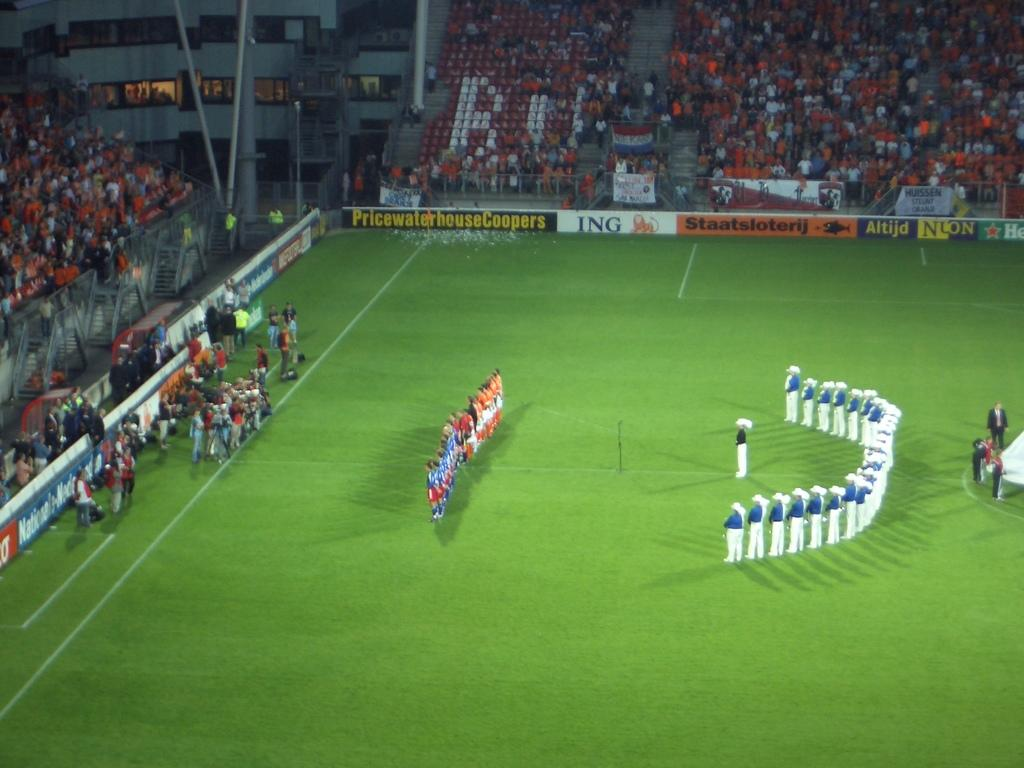<image>
Present a compact description of the photo's key features. The soccer team lines up at midfield in a stadium with banners for ING and Saatsloterij. 